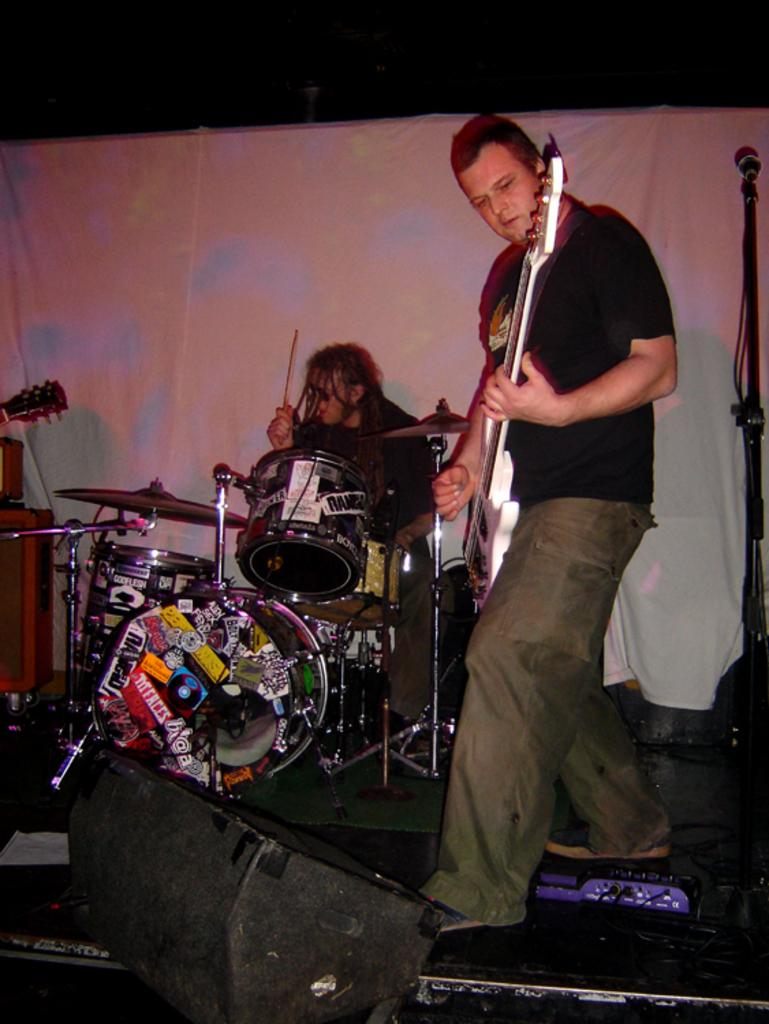What is the man in the image doing? The man is playing a guitar in the image. How is the man positioned while playing the guitar? The man is sitting while playing the guitar. What can be seen in the background of the image? There is a white color curtain in the image. What equipment is present for amplifying sound? There is a mic with a holder in the image. How many girls are playing with a vegetable in the image? There are no girls or vegetables present in the image. 